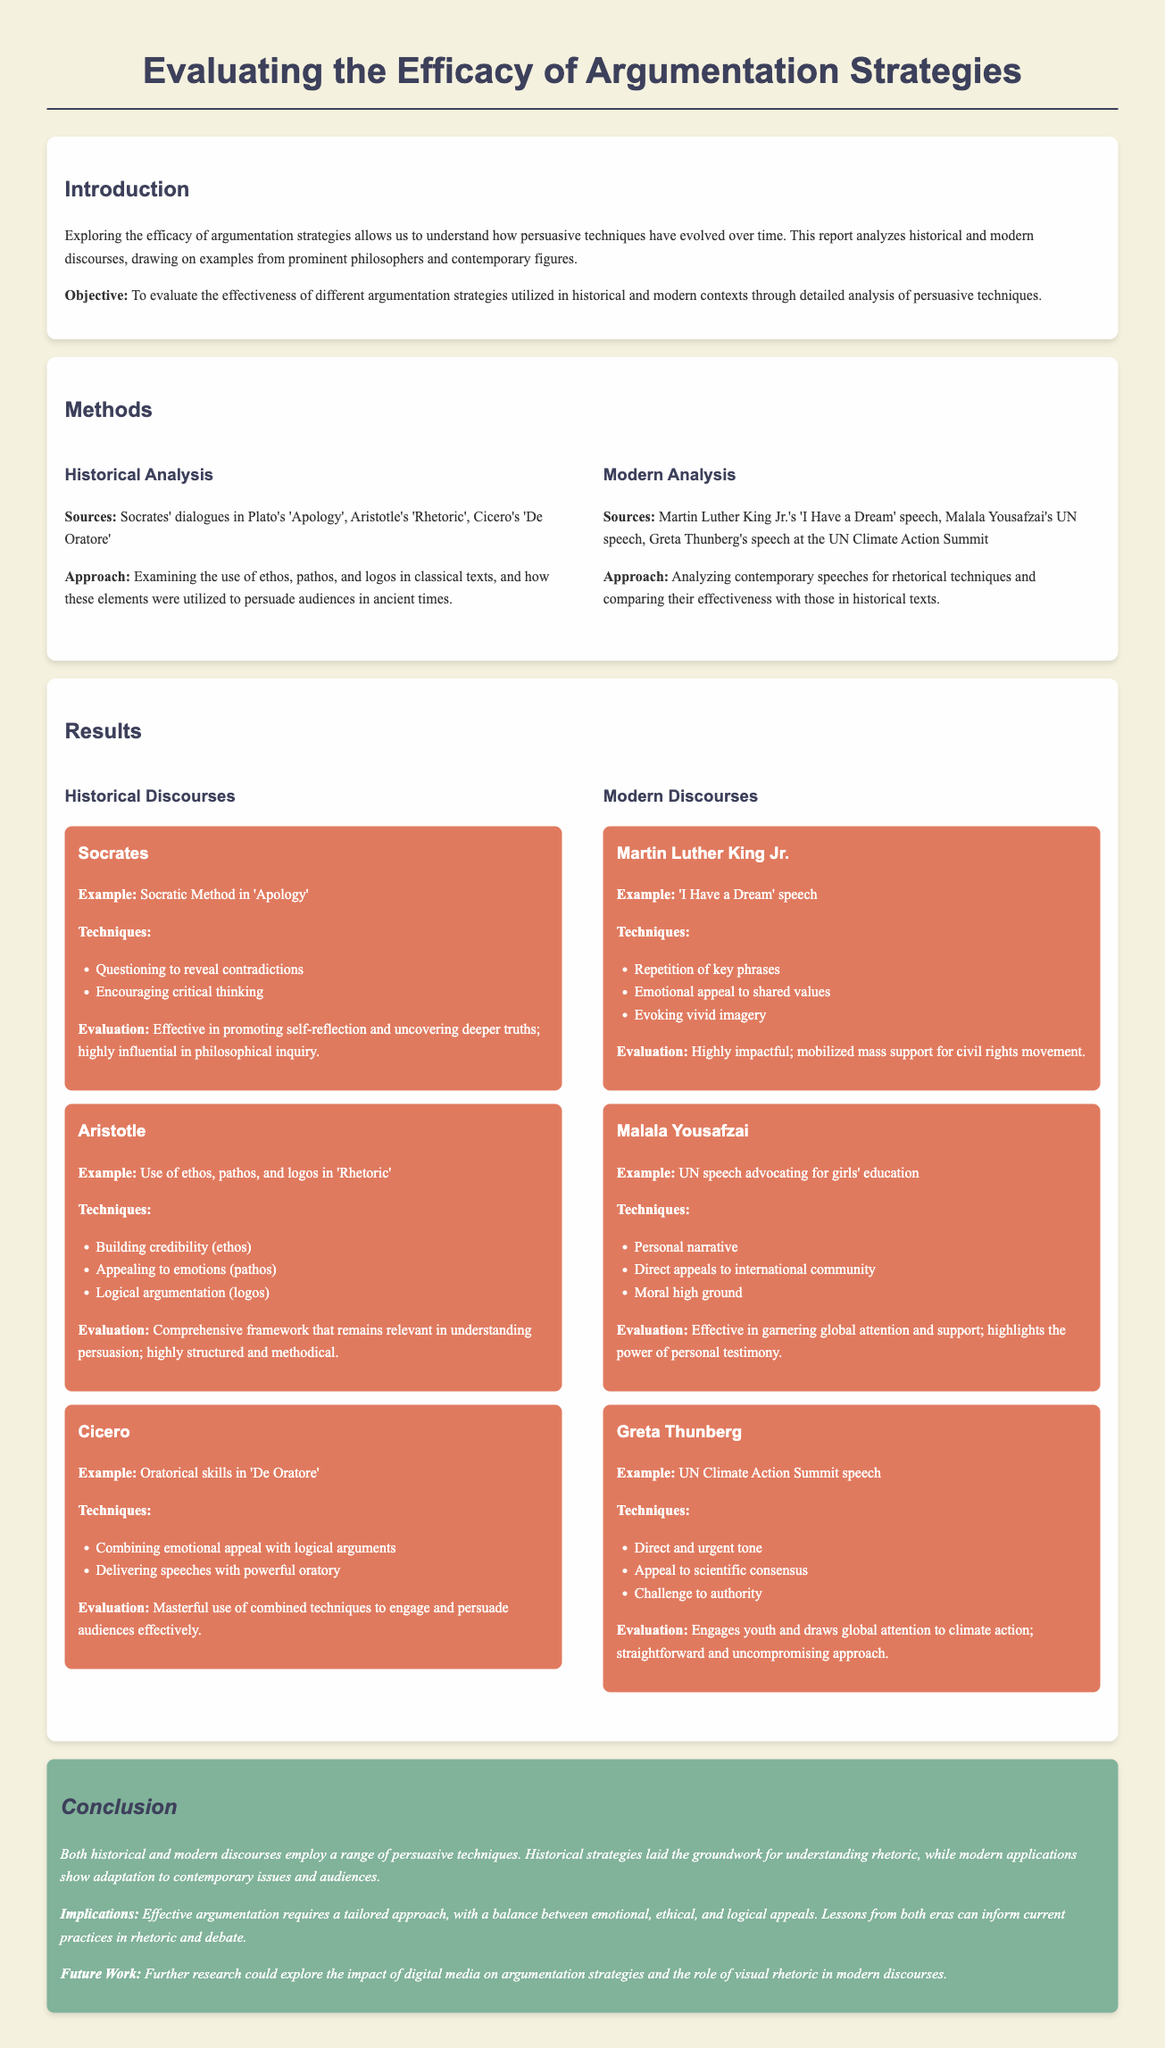what is the title of the lab report? The title is prominently displayed at the top of the document, focusing on argumentation strategies.
Answer: Evaluating the Efficacy of Argumentation Strategies: Analyzing Persuasive Techniques in Historical and Modern Discourses who are two historical figures referenced in the methods section? The methods section lists historical sources used for analysis, including key philosophers.
Answer: Socrates and Aristotle which modern figure delivered the 'I Have a Dream' speech? The results section identifies speeches and their speakers, highlighting prominent modern discourses.
Answer: Martin Luther King Jr what persuasive technique is associated with Greta Thunberg's UN speech? The results section outlines specific techniques used by modern speakers, including Thunberg.
Answer: Direct and urgent tone what is the objective of the lab report? The objective is stated in the introduction, outlining the purpose of the analysis conducted.
Answer: To evaluate the effectiveness of different argumentation strategies utilized in historical and modern contexts through detailed analysis of persuasive techniques which philosophical work emphasizes the use of ethos, pathos, and logos? This information is found in the historical analysis section, detailing Aristotle's contributions.
Answer: Rhetoric what are the implications mentioned in the conclusion? The conclusion summarizes the findings and discusses the relevance of effective argumentation today.
Answer: Effective argumentation requires a tailored approach, with a balance between emotional, ethical, and logical appeals who delivered a speech advocating for girls' education at the UN? The results section mentions several modern discourses along with their speakers.
Answer: Malala Yousafzai what is the primary method of analysis used in the historical discourse section? The methods section describes the focus of analysis utilized in historical texts regarding persuasive techniques.
Answer: Examining the use of ethos, pathos, and logos in classical texts 